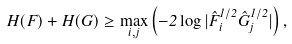Convert formula to latex. <formula><loc_0><loc_0><loc_500><loc_500>H ( F ) + H ( G ) \geq \max _ { i , j } \left ( - 2 \log | \hat { F } ^ { 1 / 2 } _ { i } \hat { G } ^ { 1 / 2 } _ { j } | \right ) ,</formula> 